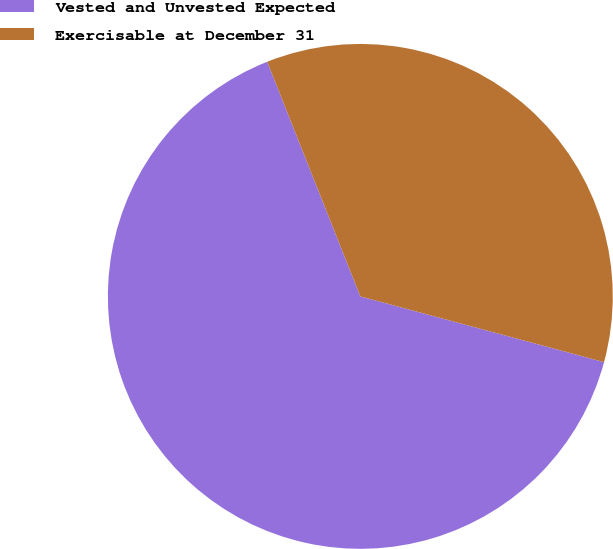Convert chart to OTSL. <chart><loc_0><loc_0><loc_500><loc_500><pie_chart><fcel>Vested and Unvested Expected<fcel>Exercisable at December 31<nl><fcel>64.79%<fcel>35.21%<nl></chart> 